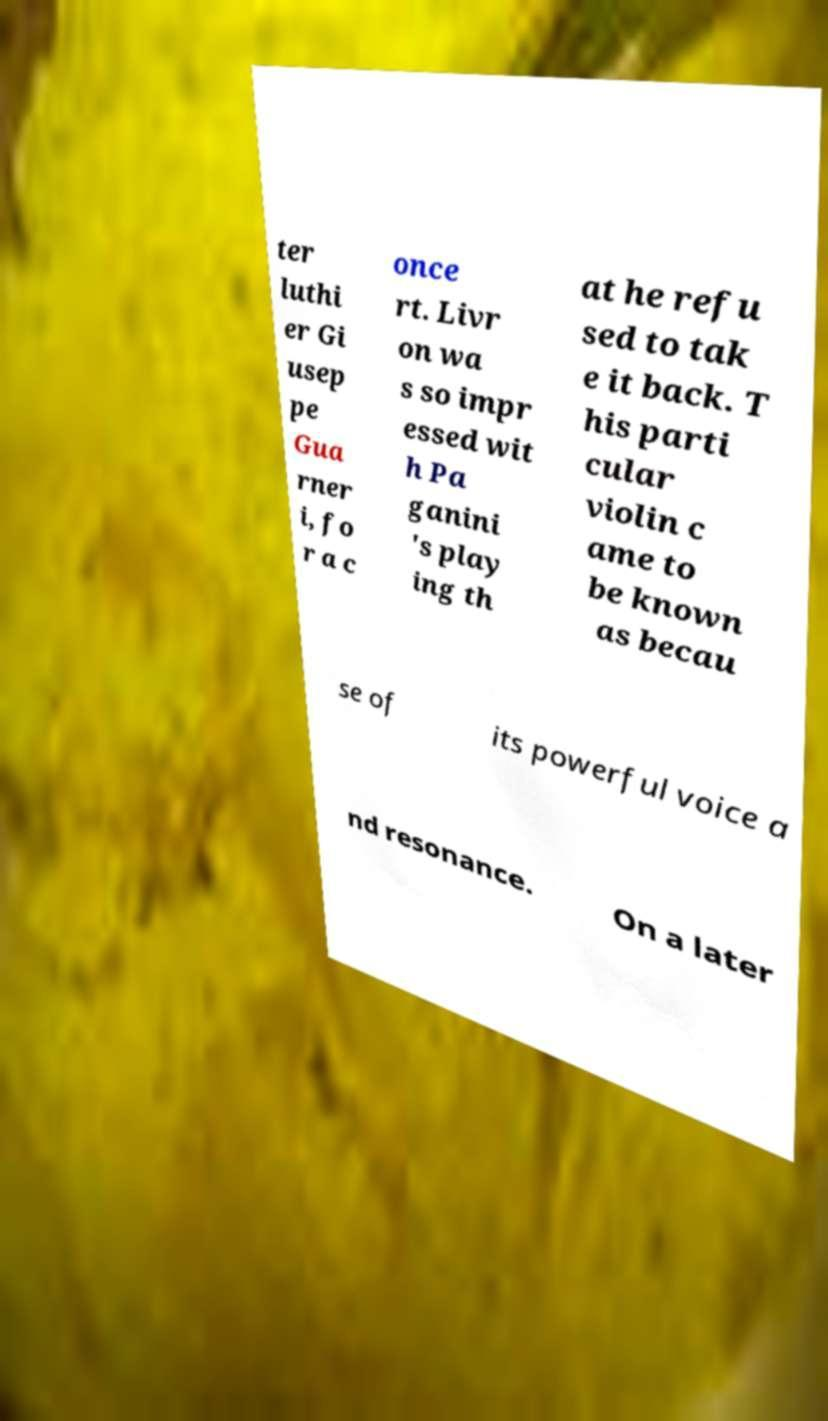For documentation purposes, I need the text within this image transcribed. Could you provide that? ter luthi er Gi usep pe Gua rner i, fo r a c once rt. Livr on wa s so impr essed wit h Pa ganini 's play ing th at he refu sed to tak e it back. T his parti cular violin c ame to be known as becau se of its powerful voice a nd resonance. On a later 